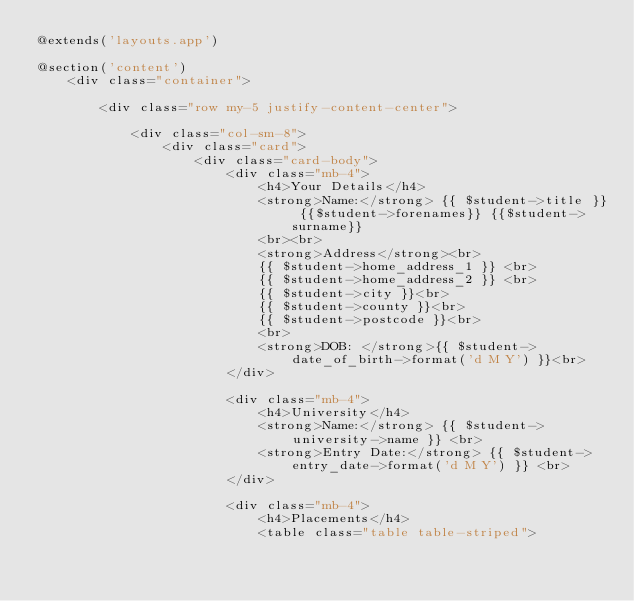Convert code to text. <code><loc_0><loc_0><loc_500><loc_500><_PHP_>@extends('layouts.app')

@section('content')
    <div class="container">

        <div class="row my-5 justify-content-center">

            <div class="col-sm-8">
                <div class="card">
                    <div class="card-body">
                        <div class="mb-4">
                            <h4>Your Details</h4>
                            <strong>Name:</strong> {{ $student->title }} {{$student->forenames}} {{$student->surname}}
                            <br><br>
                            <strong>Address</strong><br>
                            {{ $student->home_address_1 }} <br>
                            {{ $student->home_address_2 }} <br>
                            {{ $student->city }}<br>
                            {{ $student->county }}<br>
                            {{ $student->postcode }}<br>
                            <br>
                            <strong>DOB: </strong>{{ $student->date_of_birth->format('d M Y') }}<br>
                        </div>

                        <div class="mb-4">
                            <h4>University</h4>
                            <strong>Name:</strong> {{ $student->university->name }} <br>
                            <strong>Entry Date:</strong> {{ $student->entry_date->format('d M Y') }} <br>
                        </div>

                        <div class="mb-4">
                            <h4>Placements</h4>
                            <table class="table table-striped"></code> 